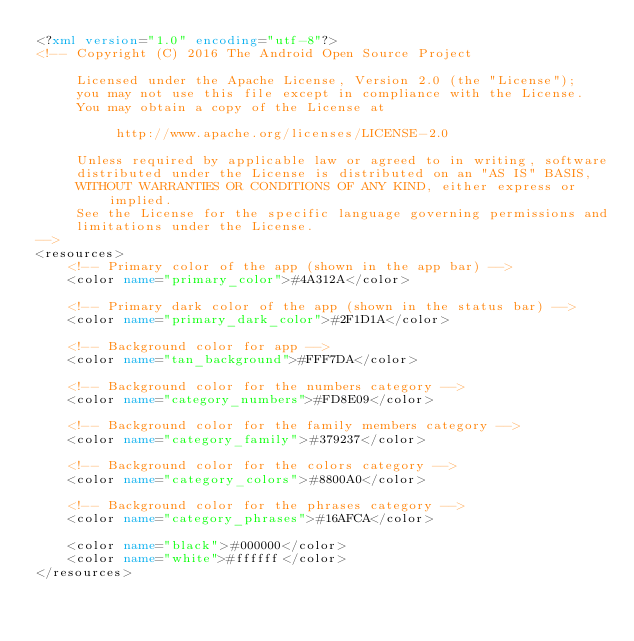<code> <loc_0><loc_0><loc_500><loc_500><_XML_><?xml version="1.0" encoding="utf-8"?>
<!-- Copyright (C) 2016 The Android Open Source Project

     Licensed under the Apache License, Version 2.0 (the "License");
     you may not use this file except in compliance with the License.
     You may obtain a copy of the License at

          http://www.apache.org/licenses/LICENSE-2.0

     Unless required by applicable law or agreed to in writing, software
     distributed under the License is distributed on an "AS IS" BASIS,
     WITHOUT WARRANTIES OR CONDITIONS OF ANY KIND, either express or implied.
     See the License for the specific language governing permissions and
     limitations under the License.
-->
<resources>
    <!-- Primary color of the app (shown in the app bar) -->
    <color name="primary_color">#4A312A</color>

    <!-- Primary dark color of the app (shown in the status bar) -->
    <color name="primary_dark_color">#2F1D1A</color>

    <!-- Background color for app -->
    <color name="tan_background">#FFF7DA</color>

    <!-- Background color for the numbers category -->
    <color name="category_numbers">#FD8E09</color>

    <!-- Background color for the family members category -->
    <color name="category_family">#379237</color>

    <!-- Background color for the colors category -->
    <color name="category_colors">#8800A0</color>

    <!-- Background color for the phrases category -->
    <color name="category_phrases">#16AFCA</color>

    <color name="black">#000000</color>
    <color name="white">#ffffff</color>
</resources>
</code> 